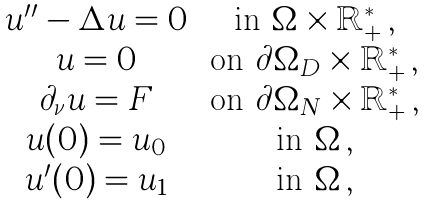Convert formula to latex. <formula><loc_0><loc_0><loc_500><loc_500>\begin{matrix} u ^ { \prime \prime } - \Delta u = 0 \, & \text {in } \Omega \times \mathbb { R } ^ { * } _ { + } \, , \\ u = 0 \, & \text {on } \partial \Omega _ { D } \times \mathbb { R } ^ { * } _ { + } \, , \\ \partial _ { \nu } u = F \, & \text {on } \partial \Omega _ { N } \times \mathbb { R } ^ { * } _ { + } \, , \\ u ( 0 ) = u _ { 0 } \, & \text {in } \Omega \, , \\ u ^ { \prime } ( 0 ) = u _ { 1 } \, & \text {in } \Omega \, , \end{matrix}</formula> 